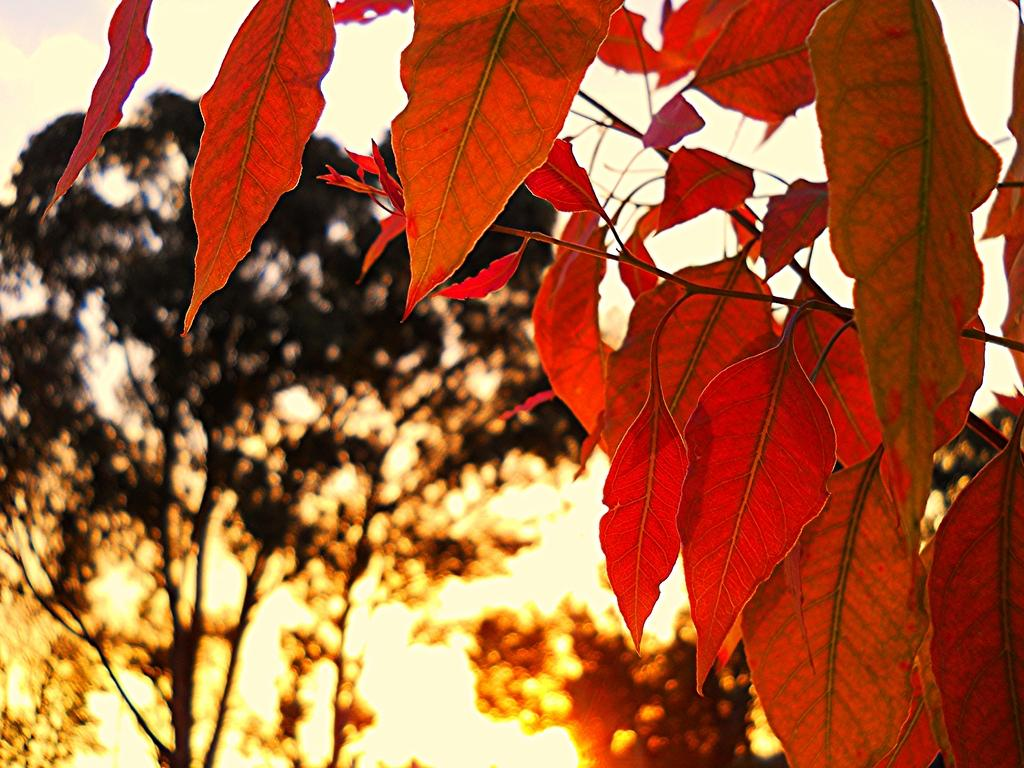What type of vegetation can be seen in the image? The image contains trees. What color are the leaves on the right side of the image? The leaves on the right side of the image are red-colored. What can be seen in the background of the image? There is sunlight visible in the background of the image. What is visible at the top of the image? The sky is visible at the top of the image. What type of agreement is being discussed in the image? There is no discussion or agreement present in the image; it features trees with red-colored leaves, sunlight, and the sky. Can you see a crib in the image? There is no crib present in the image. 